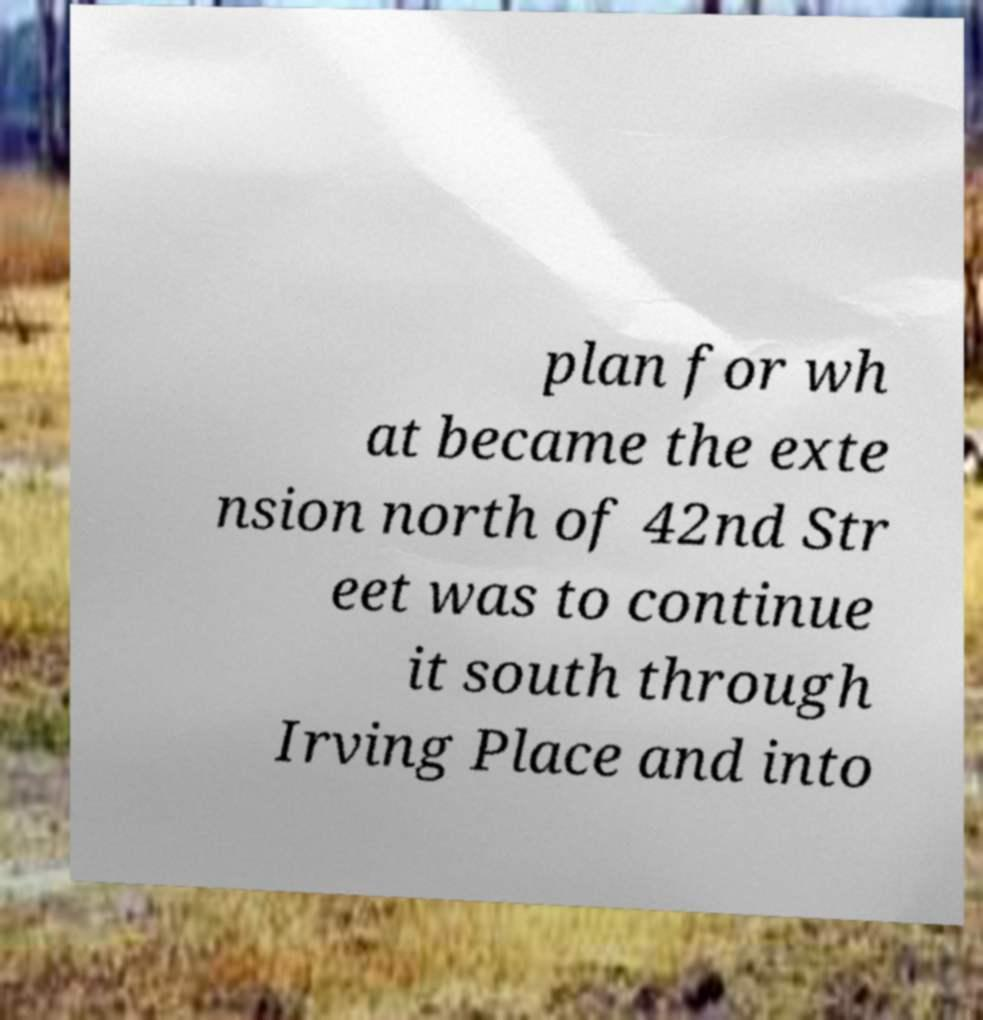For documentation purposes, I need the text within this image transcribed. Could you provide that? plan for wh at became the exte nsion north of 42nd Str eet was to continue it south through Irving Place and into 